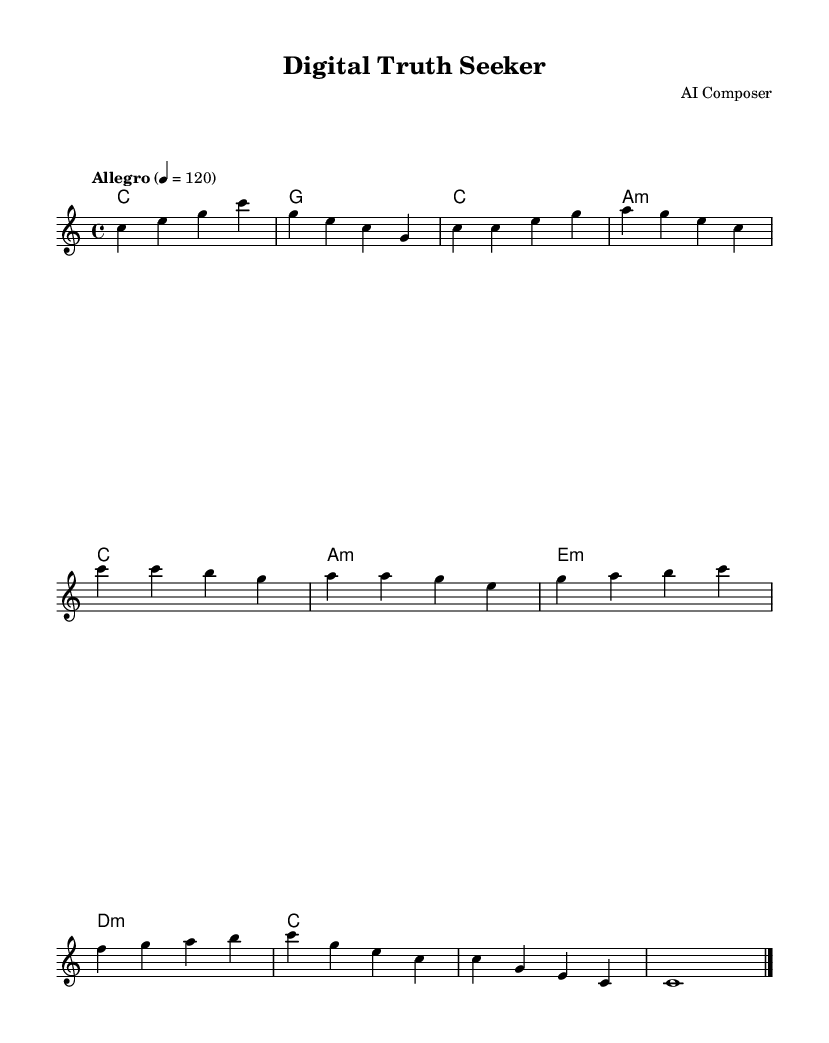What is the key signature of this music? The key signature is C major, which has no sharps or flats.
Answer: C major What is the time signature of this music? The time signature is indicated by the "4/4" notation, meaning there are four beats in a measure and the quarter note gets one beat.
Answer: 4/4 What is the tempo marking for this piece? The tempo marking is indicated as "Allegro" with a metronome indication of quarter note equals 120, suggesting a fast and lively speed.
Answer: Allegro How many measures are in the melody section? Counting the sections within the melody, there are 16 measures total from the intro, verse, chorus, bridge, and outro combined.
Answer: 16 What chord follows the A minor in the verse? The following chord in the music after the A minor is indicated to be a C major chord according to the harmony section of the sheet music.
Answer: C What section comes after the chorus? After the chorus, according to the arrangement of the music, the next section is the bridge, which is indicated in the structure of the piece.
Answer: Bridge What is the last note of the outro? The last note of the outro is a C note, indicated by the "c1" in the final measure, marking the end of the piece.
Answer: C 